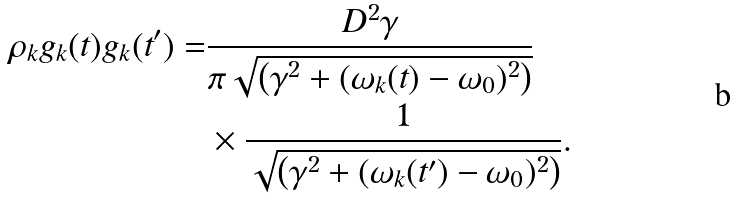Convert formula to latex. <formula><loc_0><loc_0><loc_500><loc_500>\rho _ { k } g _ { k } ( t ) g _ { k } ( t ^ { \prime } ) = & \frac { D ^ { 2 } \gamma } { \pi \sqrt { \left ( \gamma ^ { 2 } + ( \omega _ { k } ( t ) - \omega _ { 0 } ) ^ { 2 } \right ) } } \\ & \times \frac { 1 } { \sqrt { \left ( \gamma ^ { 2 } + ( \omega _ { k } ( t ^ { \prime } ) - \omega _ { 0 } ) ^ { 2 } \right ) } } .</formula> 